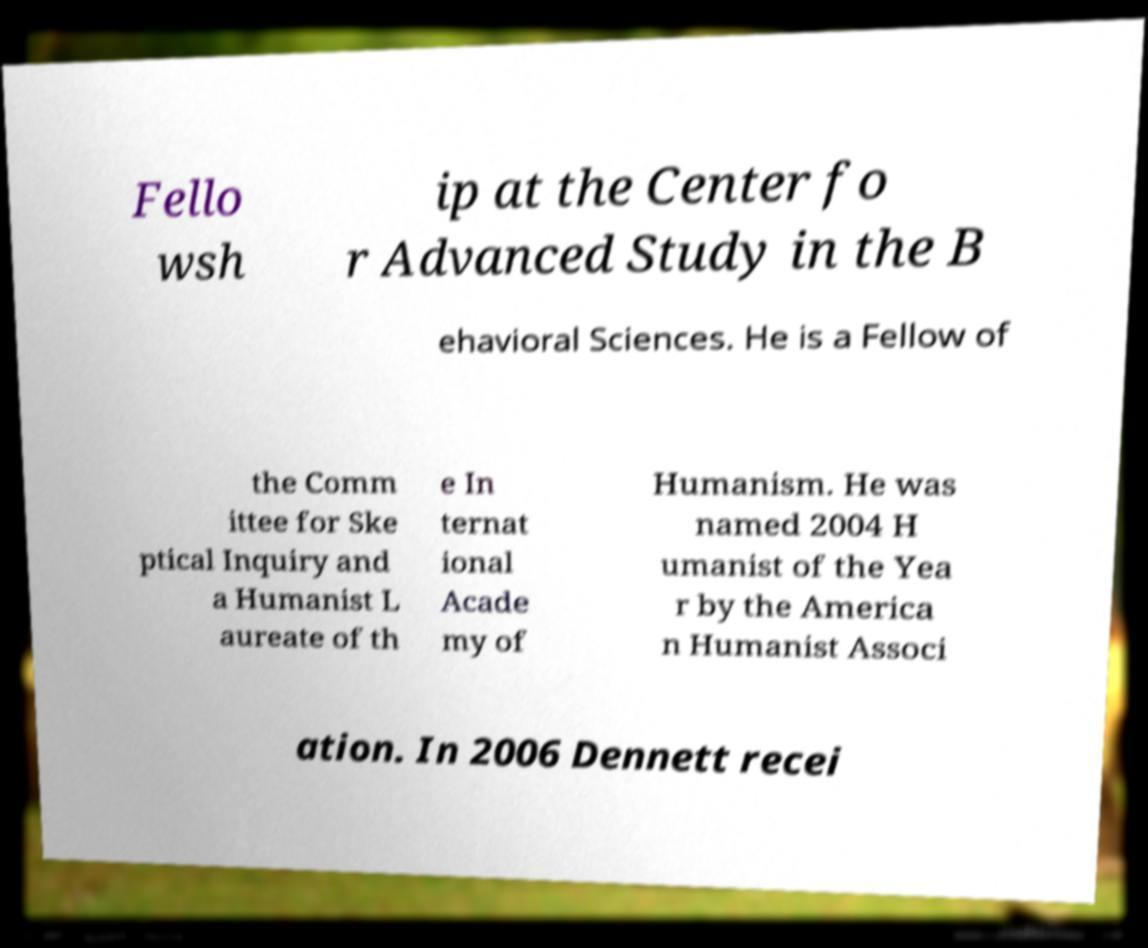Could you extract and type out the text from this image? Fello wsh ip at the Center fo r Advanced Study in the B ehavioral Sciences. He is a Fellow of the Comm ittee for Ske ptical Inquiry and a Humanist L aureate of th e In ternat ional Acade my of Humanism. He was named 2004 H umanist of the Yea r by the America n Humanist Associ ation. In 2006 Dennett recei 